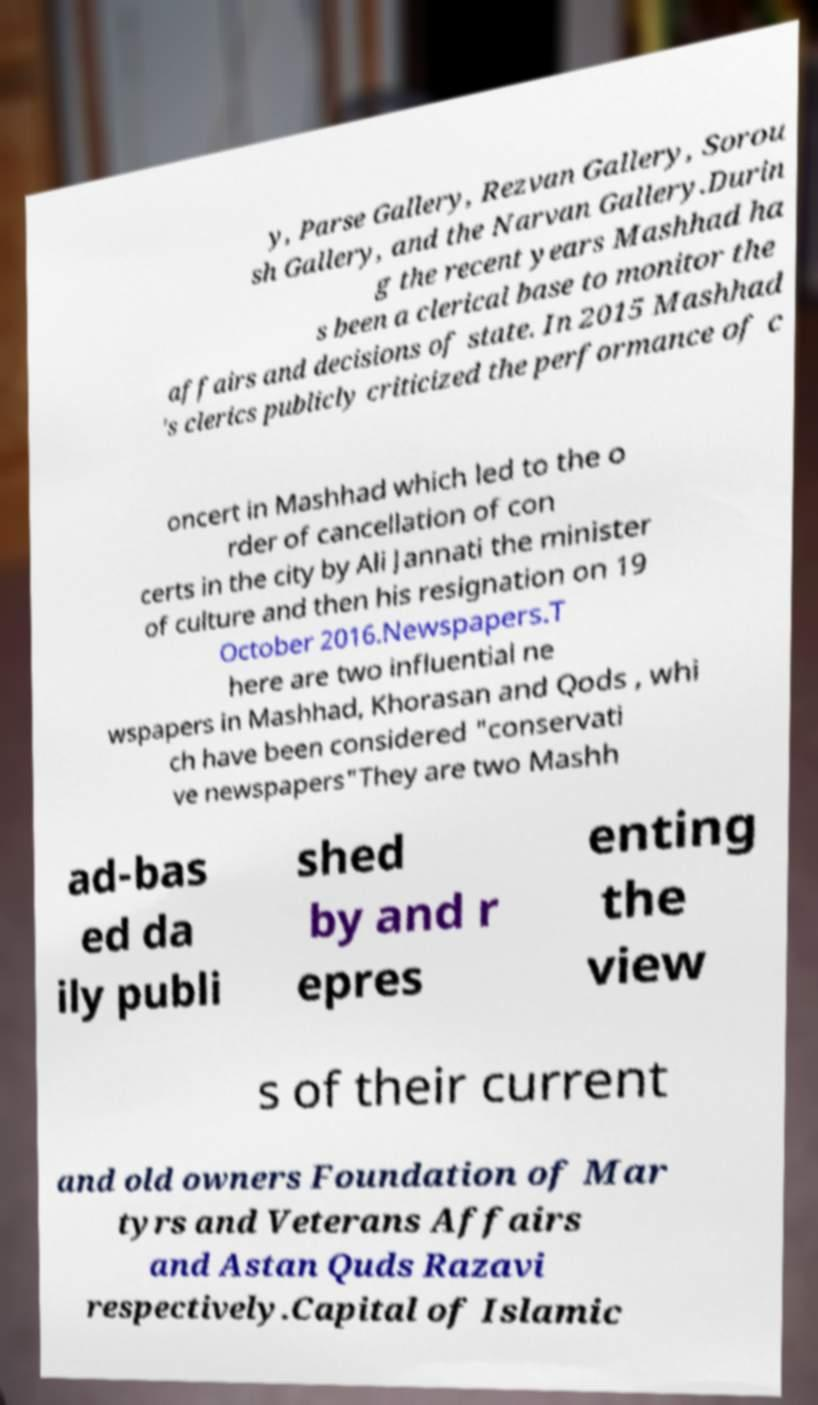There's text embedded in this image that I need extracted. Can you transcribe it verbatim? y, Parse Gallery, Rezvan Gallery, Sorou sh Gallery, and the Narvan Gallery.Durin g the recent years Mashhad ha s been a clerical base to monitor the affairs and decisions of state. In 2015 Mashhad 's clerics publicly criticized the performance of c oncert in Mashhad which led to the o rder of cancellation of con certs in the city by Ali Jannati the minister of culture and then his resignation on 19 October 2016.Newspapers.T here are two influential ne wspapers in Mashhad, Khorasan and Qods , whi ch have been considered "conservati ve newspapers"They are two Mashh ad-bas ed da ily publi shed by and r epres enting the view s of their current and old owners Foundation of Mar tyrs and Veterans Affairs and Astan Quds Razavi respectively.Capital of Islamic 